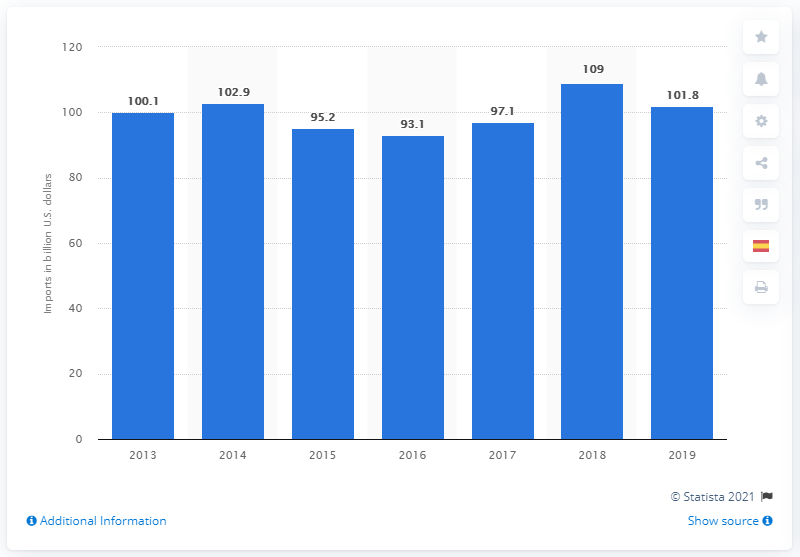Draw attention to some important aspects in this diagram. In 2019, the value of chemical imports into the United States was $101.8 billion. In 2013, the value of chemical imports into the United States was 100.1. 